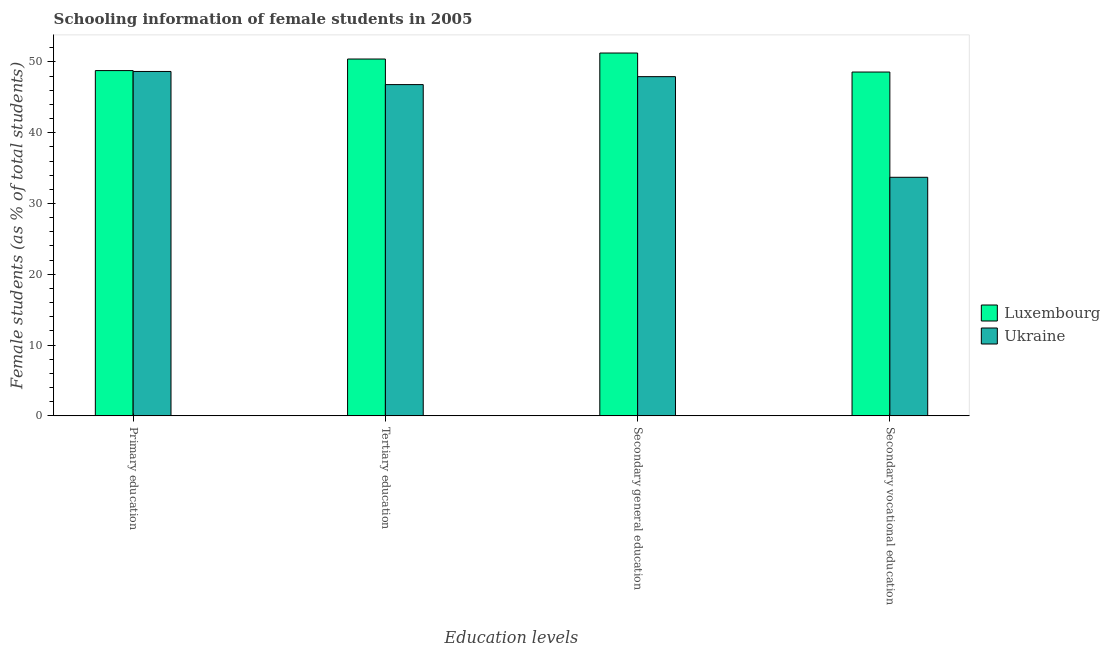How many different coloured bars are there?
Your answer should be very brief. 2. How many groups of bars are there?
Offer a very short reply. 4. Are the number of bars per tick equal to the number of legend labels?
Provide a short and direct response. Yes. Are the number of bars on each tick of the X-axis equal?
Make the answer very short. Yes. How many bars are there on the 1st tick from the left?
Provide a short and direct response. 2. What is the label of the 3rd group of bars from the left?
Make the answer very short. Secondary general education. What is the percentage of female students in secondary education in Ukraine?
Your response must be concise. 47.91. Across all countries, what is the maximum percentage of female students in primary education?
Your response must be concise. 48.77. Across all countries, what is the minimum percentage of female students in secondary education?
Make the answer very short. 47.91. In which country was the percentage of female students in tertiary education maximum?
Keep it short and to the point. Luxembourg. In which country was the percentage of female students in tertiary education minimum?
Ensure brevity in your answer.  Ukraine. What is the total percentage of female students in tertiary education in the graph?
Keep it short and to the point. 97.2. What is the difference between the percentage of female students in tertiary education in Ukraine and that in Luxembourg?
Make the answer very short. -3.61. What is the difference between the percentage of female students in tertiary education in Luxembourg and the percentage of female students in primary education in Ukraine?
Your response must be concise. 1.76. What is the average percentage of female students in secondary education per country?
Your answer should be very brief. 49.58. What is the difference between the percentage of female students in secondary vocational education and percentage of female students in secondary education in Luxembourg?
Your response must be concise. -2.69. What is the ratio of the percentage of female students in secondary education in Luxembourg to that in Ukraine?
Provide a short and direct response. 1.07. Is the percentage of female students in secondary vocational education in Ukraine less than that in Luxembourg?
Your answer should be compact. Yes. What is the difference between the highest and the second highest percentage of female students in tertiary education?
Give a very brief answer. 3.61. What is the difference between the highest and the lowest percentage of female students in secondary education?
Keep it short and to the point. 3.34. Is the sum of the percentage of female students in secondary vocational education in Ukraine and Luxembourg greater than the maximum percentage of female students in primary education across all countries?
Your answer should be compact. Yes. What does the 2nd bar from the left in Primary education represents?
Your answer should be compact. Ukraine. What does the 1st bar from the right in Secondary vocational education represents?
Your response must be concise. Ukraine. How many countries are there in the graph?
Provide a succinct answer. 2. What is the difference between two consecutive major ticks on the Y-axis?
Offer a very short reply. 10. Are the values on the major ticks of Y-axis written in scientific E-notation?
Keep it short and to the point. No. How many legend labels are there?
Provide a succinct answer. 2. How are the legend labels stacked?
Your answer should be very brief. Vertical. What is the title of the graph?
Ensure brevity in your answer.  Schooling information of female students in 2005. What is the label or title of the X-axis?
Ensure brevity in your answer.  Education levels. What is the label or title of the Y-axis?
Make the answer very short. Female students (as % of total students). What is the Female students (as % of total students) of Luxembourg in Primary education?
Your answer should be compact. 48.77. What is the Female students (as % of total students) in Ukraine in Primary education?
Give a very brief answer. 48.65. What is the Female students (as % of total students) of Luxembourg in Tertiary education?
Your answer should be very brief. 50.41. What is the Female students (as % of total students) in Ukraine in Tertiary education?
Your response must be concise. 46.79. What is the Female students (as % of total students) of Luxembourg in Secondary general education?
Provide a succinct answer. 51.25. What is the Female students (as % of total students) of Ukraine in Secondary general education?
Your answer should be compact. 47.91. What is the Female students (as % of total students) in Luxembourg in Secondary vocational education?
Keep it short and to the point. 48.57. What is the Female students (as % of total students) of Ukraine in Secondary vocational education?
Keep it short and to the point. 33.7. Across all Education levels, what is the maximum Female students (as % of total students) in Luxembourg?
Keep it short and to the point. 51.25. Across all Education levels, what is the maximum Female students (as % of total students) of Ukraine?
Your response must be concise. 48.65. Across all Education levels, what is the minimum Female students (as % of total students) of Luxembourg?
Keep it short and to the point. 48.57. Across all Education levels, what is the minimum Female students (as % of total students) in Ukraine?
Your answer should be very brief. 33.7. What is the total Female students (as % of total students) in Luxembourg in the graph?
Give a very brief answer. 199. What is the total Female students (as % of total students) in Ukraine in the graph?
Offer a very short reply. 177.05. What is the difference between the Female students (as % of total students) in Luxembourg in Primary education and that in Tertiary education?
Your answer should be compact. -1.63. What is the difference between the Female students (as % of total students) in Ukraine in Primary education and that in Tertiary education?
Give a very brief answer. 1.86. What is the difference between the Female students (as % of total students) of Luxembourg in Primary education and that in Secondary general education?
Make the answer very short. -2.48. What is the difference between the Female students (as % of total students) in Ukraine in Primary education and that in Secondary general education?
Provide a succinct answer. 0.73. What is the difference between the Female students (as % of total students) in Luxembourg in Primary education and that in Secondary vocational education?
Offer a very short reply. 0.21. What is the difference between the Female students (as % of total students) of Ukraine in Primary education and that in Secondary vocational education?
Offer a terse response. 14.95. What is the difference between the Female students (as % of total students) of Luxembourg in Tertiary education and that in Secondary general education?
Make the answer very short. -0.85. What is the difference between the Female students (as % of total students) of Ukraine in Tertiary education and that in Secondary general education?
Offer a very short reply. -1.12. What is the difference between the Female students (as % of total students) in Luxembourg in Tertiary education and that in Secondary vocational education?
Your answer should be very brief. 1.84. What is the difference between the Female students (as % of total students) in Ukraine in Tertiary education and that in Secondary vocational education?
Ensure brevity in your answer.  13.09. What is the difference between the Female students (as % of total students) of Luxembourg in Secondary general education and that in Secondary vocational education?
Provide a short and direct response. 2.69. What is the difference between the Female students (as % of total students) in Ukraine in Secondary general education and that in Secondary vocational education?
Make the answer very short. 14.21. What is the difference between the Female students (as % of total students) of Luxembourg in Primary education and the Female students (as % of total students) of Ukraine in Tertiary education?
Ensure brevity in your answer.  1.98. What is the difference between the Female students (as % of total students) in Luxembourg in Primary education and the Female students (as % of total students) in Ukraine in Secondary general education?
Give a very brief answer. 0.86. What is the difference between the Female students (as % of total students) in Luxembourg in Primary education and the Female students (as % of total students) in Ukraine in Secondary vocational education?
Your answer should be compact. 15.07. What is the difference between the Female students (as % of total students) of Luxembourg in Tertiary education and the Female students (as % of total students) of Ukraine in Secondary general education?
Provide a succinct answer. 2.49. What is the difference between the Female students (as % of total students) in Luxembourg in Tertiary education and the Female students (as % of total students) in Ukraine in Secondary vocational education?
Keep it short and to the point. 16.71. What is the difference between the Female students (as % of total students) in Luxembourg in Secondary general education and the Female students (as % of total students) in Ukraine in Secondary vocational education?
Keep it short and to the point. 17.55. What is the average Female students (as % of total students) in Luxembourg per Education levels?
Your answer should be compact. 49.75. What is the average Female students (as % of total students) of Ukraine per Education levels?
Offer a very short reply. 44.26. What is the difference between the Female students (as % of total students) in Luxembourg and Female students (as % of total students) in Ukraine in Primary education?
Your answer should be very brief. 0.12. What is the difference between the Female students (as % of total students) of Luxembourg and Female students (as % of total students) of Ukraine in Tertiary education?
Your answer should be very brief. 3.61. What is the difference between the Female students (as % of total students) of Luxembourg and Female students (as % of total students) of Ukraine in Secondary general education?
Offer a terse response. 3.34. What is the difference between the Female students (as % of total students) of Luxembourg and Female students (as % of total students) of Ukraine in Secondary vocational education?
Offer a very short reply. 14.87. What is the ratio of the Female students (as % of total students) in Luxembourg in Primary education to that in Tertiary education?
Make the answer very short. 0.97. What is the ratio of the Female students (as % of total students) of Ukraine in Primary education to that in Tertiary education?
Ensure brevity in your answer.  1.04. What is the ratio of the Female students (as % of total students) of Luxembourg in Primary education to that in Secondary general education?
Keep it short and to the point. 0.95. What is the ratio of the Female students (as % of total students) in Ukraine in Primary education to that in Secondary general education?
Your answer should be very brief. 1.02. What is the ratio of the Female students (as % of total students) in Luxembourg in Primary education to that in Secondary vocational education?
Ensure brevity in your answer.  1. What is the ratio of the Female students (as % of total students) in Ukraine in Primary education to that in Secondary vocational education?
Provide a short and direct response. 1.44. What is the ratio of the Female students (as % of total students) of Luxembourg in Tertiary education to that in Secondary general education?
Keep it short and to the point. 0.98. What is the ratio of the Female students (as % of total students) in Ukraine in Tertiary education to that in Secondary general education?
Your response must be concise. 0.98. What is the ratio of the Female students (as % of total students) of Luxembourg in Tertiary education to that in Secondary vocational education?
Offer a terse response. 1.04. What is the ratio of the Female students (as % of total students) of Ukraine in Tertiary education to that in Secondary vocational education?
Your response must be concise. 1.39. What is the ratio of the Female students (as % of total students) of Luxembourg in Secondary general education to that in Secondary vocational education?
Provide a short and direct response. 1.06. What is the ratio of the Female students (as % of total students) of Ukraine in Secondary general education to that in Secondary vocational education?
Make the answer very short. 1.42. What is the difference between the highest and the second highest Female students (as % of total students) in Luxembourg?
Provide a succinct answer. 0.85. What is the difference between the highest and the second highest Female students (as % of total students) of Ukraine?
Provide a short and direct response. 0.73. What is the difference between the highest and the lowest Female students (as % of total students) in Luxembourg?
Offer a very short reply. 2.69. What is the difference between the highest and the lowest Female students (as % of total students) of Ukraine?
Your answer should be compact. 14.95. 